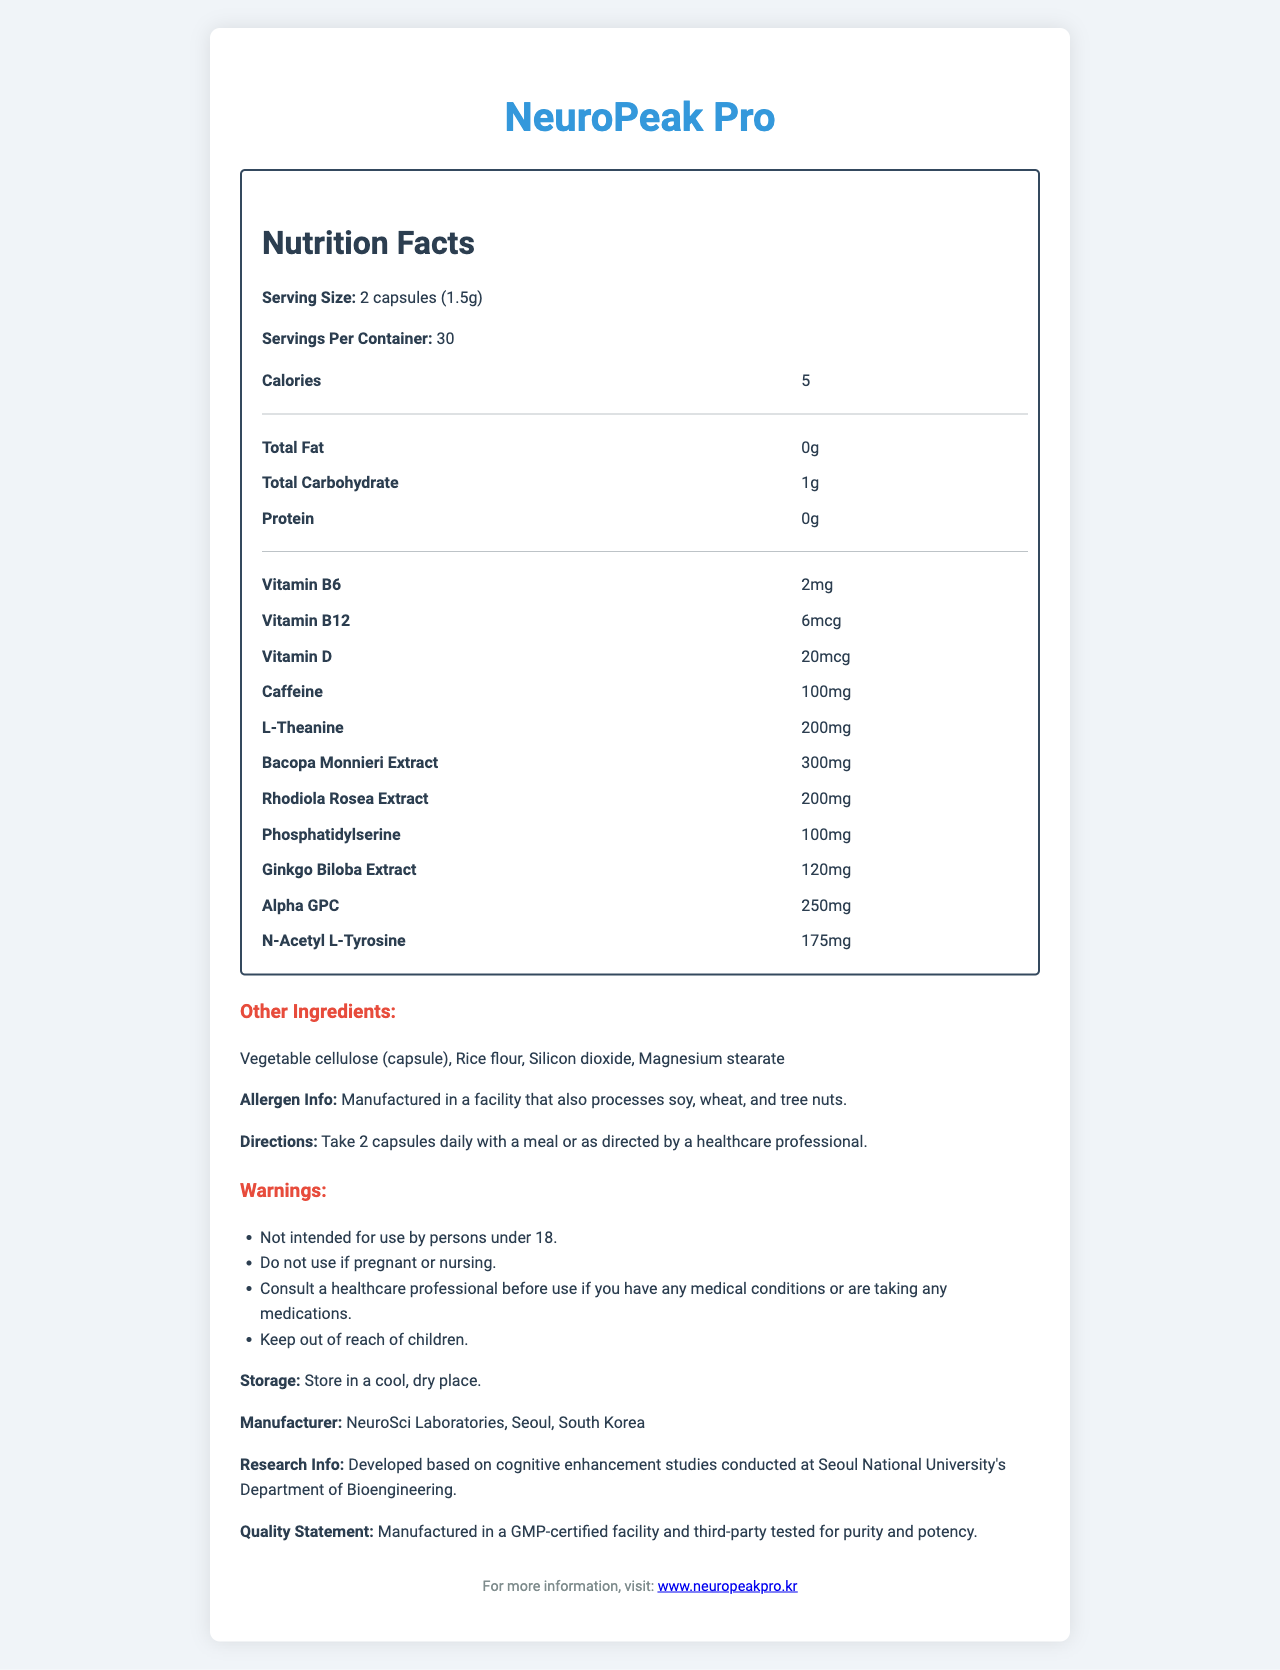what is the serving size of NeuroPeak Pro? The serving size is directly listed as "2 capsules (1.5g)" in the document.
Answer: 2 capsules (1.5g) how many calories are there per serving? The document states that there are 5 calories per serving.
Answer: 5 calories what is the amount of Caffeine per serving? The document lists the caffeine content as 100mg per serving.
Answer: 100mg what are the directions for taking NeuroPeak Pro? The directions are clearly written in the document under the directions section.
Answer: Take 2 capsules daily with a meal or as directed by a healthcare professional. list the vitamins included in NeuroPeak Pro and their amounts. The amounts and types of vitamins are directly listed in the Nutrition Facts section of the document.
Answer: Vitamin B6: 2mg, Vitamin B12: 6mcg, Vitamin D: 20mcg which ingredient is present in the highest amount? A. Ginkgo Biloba Extract B. Bacopa Monnieri Extract C. Alpha GPC D. L-Theanine Bacopa Monnieri Extract has the highest amount at 300mg, which is higher than the amounts for Ginkgo Biloba Extract (120mg), Alpha GPC (250mg), and L-Theanine (200mg).
Answer: B: Bacopa Monnieri Extract what is the total carbohydrate content per serving? A. 0g B. 1g C. 2g D. 3g The document indicates that the total carbohydrate content per serving is 1g.
Answer: B: 1g is NeuroPeak Pro intended for use by children? The warning section clearly states that it is not intended for use by persons under 18.
Answer: No what is the main idea of the document? The main idea is summarized by describing the various sections and information covered in the document about NeuroPeak Pro.
Answer: The document provides detailed nutritional information about NeuroPeak Pro, a functional food supplement aimed at enhancing cognitive performance and reducing fatigue. It includes serving size, ingredients, directions, warnings, and additional product-related information. who conducted the cognitive enhancement studies mentioned in the research information? The research information section specifies that the cognitive enhancement studies were conducted at Seoul National University's Department of Bioengineering.
Answer: Seoul National University's Department of Bioengineering what are the non-active ingredients in the capsules? These are listed under the "Other Ingredients" section in the document.
Answer: Vegetable cellulose (capsule), Rice flour, Silicon dioxide, Magnesium stearate who manufactures NeuroPeak Pro? The manufacturer is listed in the document as NeuroSci Laboratories, Seoul, South Korea.
Answer: NeuroSci Laboratories, Seoul, South Korea can the exact percentage of daily value for vitamins be determined from the document? The document does not provide the percentage of the daily value for the vitamins listed, only their quantities.
Answer: Cannot be determined 